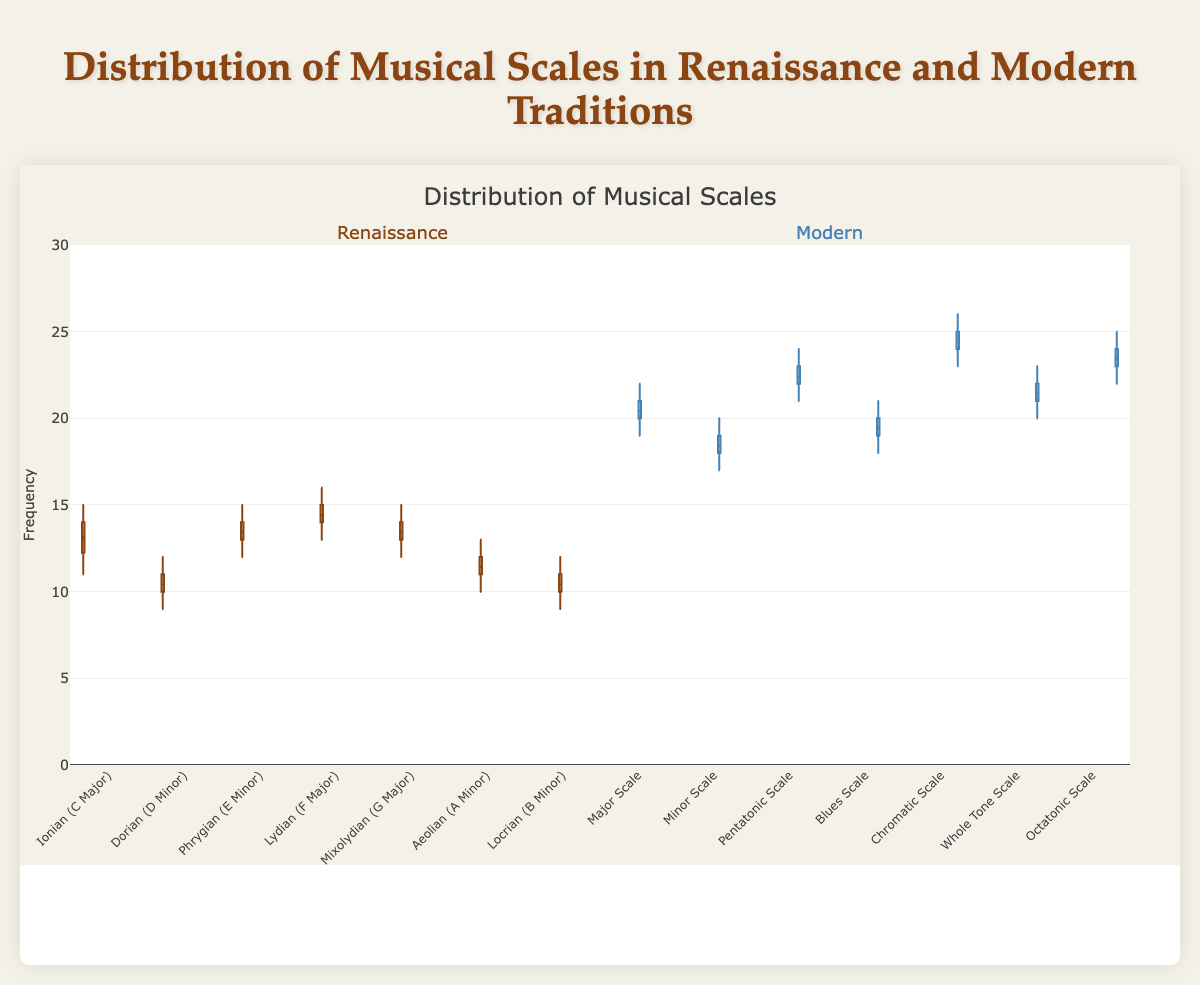How many different musical scales are represented for each tradition? The figure shows 7 box plots for each tradition, identified by the unique color representations for Renaissance and Modern musical scales. Counting the number of distinct box plots within each color category gives us the number of scales.
Answer: 7 for each tradition What is the median frequency for the Renaissance Ionian (C Major) scale? The median is represented by the line inside the box. For the Renaissance Ionian (C Major) scale, the line within the box plot corresponds to the median. Observing this line on the plot, we can find the median frequency value.
Answer: 13 How does the range of the Modern Pentatonic Scale compare to the range of the Renaissance Lydian (F Major) scale? The range of a box plot is defined as the distance between the minimum and maximum values represented by the whiskers. For the Modern Pentatonic Scale, the whiskers range from 21 to 24, making the range 3. For the Renaissance Lydian (F Major) scale, the whiskers range from 13 to 16, also making the range 3.
Answer: Both ranges are 3 Which era has a higher median frequency overall, Renaissance or Modern? To determine the overall median frequency, we need to calculate the median of the median frequencies for each scale within both traditions. From the box plots, the median frequencies for Renaissance scales are 13, 10, 13, 14, 13, 11, 10, and for the Modern scales, they are 20, 18, 22, 19, 24, 21, 23. Calculating the medians gives us 13.
Answer: Modern Which scale has the highest median frequency among all scales? The highest median frequency is represented by the horizontal line within the boxes. Looking across all box plots, the Modern Chromatic Scale has the highest median frequency. The median value for the Modern Chromatic Scale is higher than any other scale.
Answer: Modern Chromatic Scale Compare the interquartile range (IQR) of the Modern Whole Tone Scale to the Renaissance Ionian (C Major) scale. The IQR is represented by the length of the box in a box plot. For the Modern Whole Tone Scale, this range extends from the first quartile (20) to the third quartile (23), so the IQR is 3. For the Renaissance Ionian (C Major), it extends from 12 to 14, making the IQR 2.
Answer: Whole Tone: 3, Ionian: 2 Which scale in the Renaissance era shows the lowest variation in frequency? Variation can be assessed by examining the spread of the box and whiskers. The scale with the smallest box and whiskers represents the lowest variation. Looking at the Renaissance plots, the Lydian (F Major) scale displays the smallest variation.
Answer: Renaissance Lydian (F Major) What is the median difference between the Renaissance Dorian (D Minor) scale and the Modern Minor Scale? The median for Renaissance Dorian (D Minor) is 10 and for Modern Minor Scale is 18. The difference between these medians is calculated as 18 - 10.
Answer: 8 Is there any overlap between the frequency distributions of the Renaissance Phrygian (E Minor) and the Modern Blues Scale? Overlap occurs if the whiskers of the box plots intersect. Checking the whiskers of both scales, the Renaissance Phrygian (E Minor) ranges from 12 to 15, and the Modern Blues Scale ranges from 18 to 21, showing no overlapping range.
Answer: No overlap 